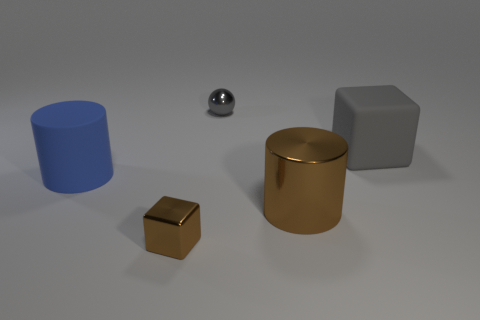What is the size of the sphere that is made of the same material as the brown cylinder?
Keep it short and to the point. Small. There is a large block that is the same color as the shiny ball; what is its material?
Offer a terse response. Rubber. There is a rubber object right of the big rubber object that is in front of the gray matte cube; what number of gray matte cubes are behind it?
Provide a succinct answer. 0. There is a block that is the same size as the metallic ball; what material is it?
Your answer should be very brief. Metal. Is there a metallic thing that has the same size as the gray cube?
Provide a succinct answer. Yes. What is the color of the small shiny ball?
Ensure brevity in your answer.  Gray. There is a big object that is to the left of the brown object behind the brown block; what is its color?
Provide a succinct answer. Blue. The tiny shiny object that is right of the brown block that is in front of the large rubber thing that is on the left side of the large gray matte block is what shape?
Give a very brief answer. Sphere. What number of small cubes are the same material as the blue cylinder?
Your answer should be very brief. 0. What number of things are in front of the small gray object that is right of the big matte cylinder?
Make the answer very short. 4. 